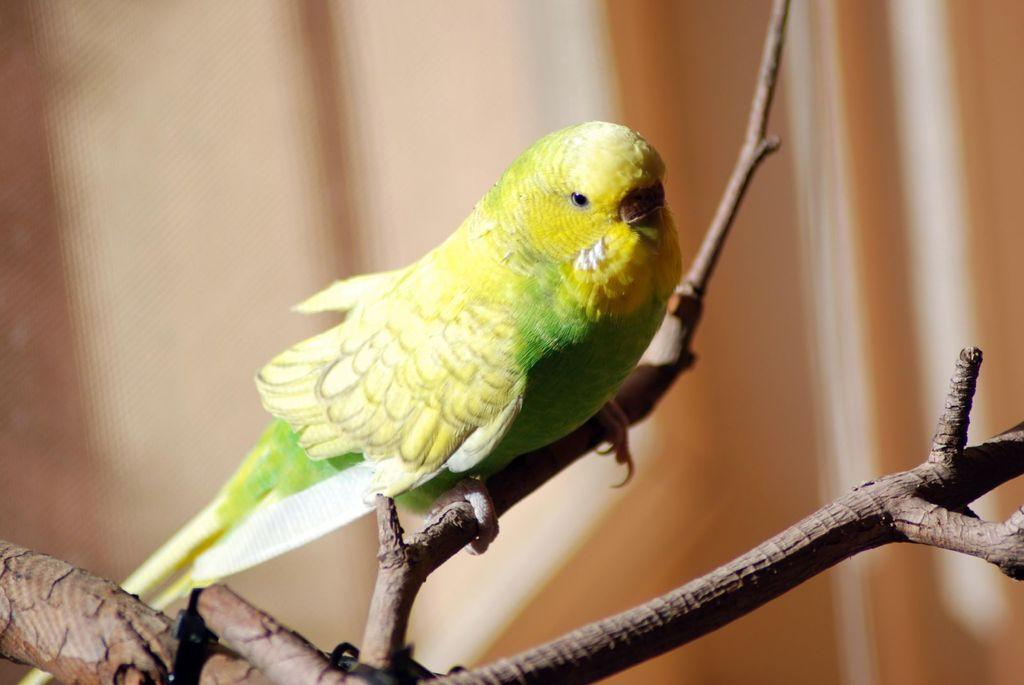What type of animal is in the image? There is a bird in the image. How is the bird positioned in the image? The bird is on a stick. Can you describe the background of the image? The background of the image is blurred. What is the bird's tendency to consume flesh in the image? There is no information about the bird's diet or tendencies in the image. 